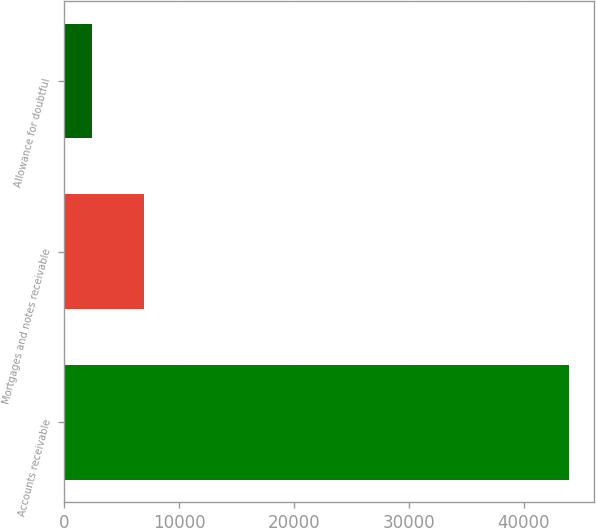<chart> <loc_0><loc_0><loc_500><loc_500><bar_chart><fcel>Accounts receivable<fcel>Mortgages and notes receivable<fcel>Allowance for doubtful<nl><fcel>43931<fcel>6912<fcel>2411<nl></chart> 